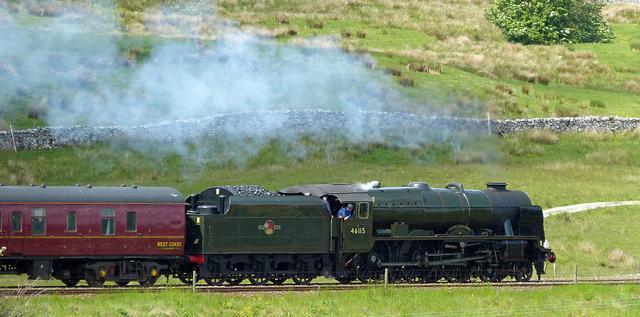Which car propels the train along the tracks?
From the following set of four choices, select the accurate answer to respond to the question.
Options: Back, none, front, middle. Front. 